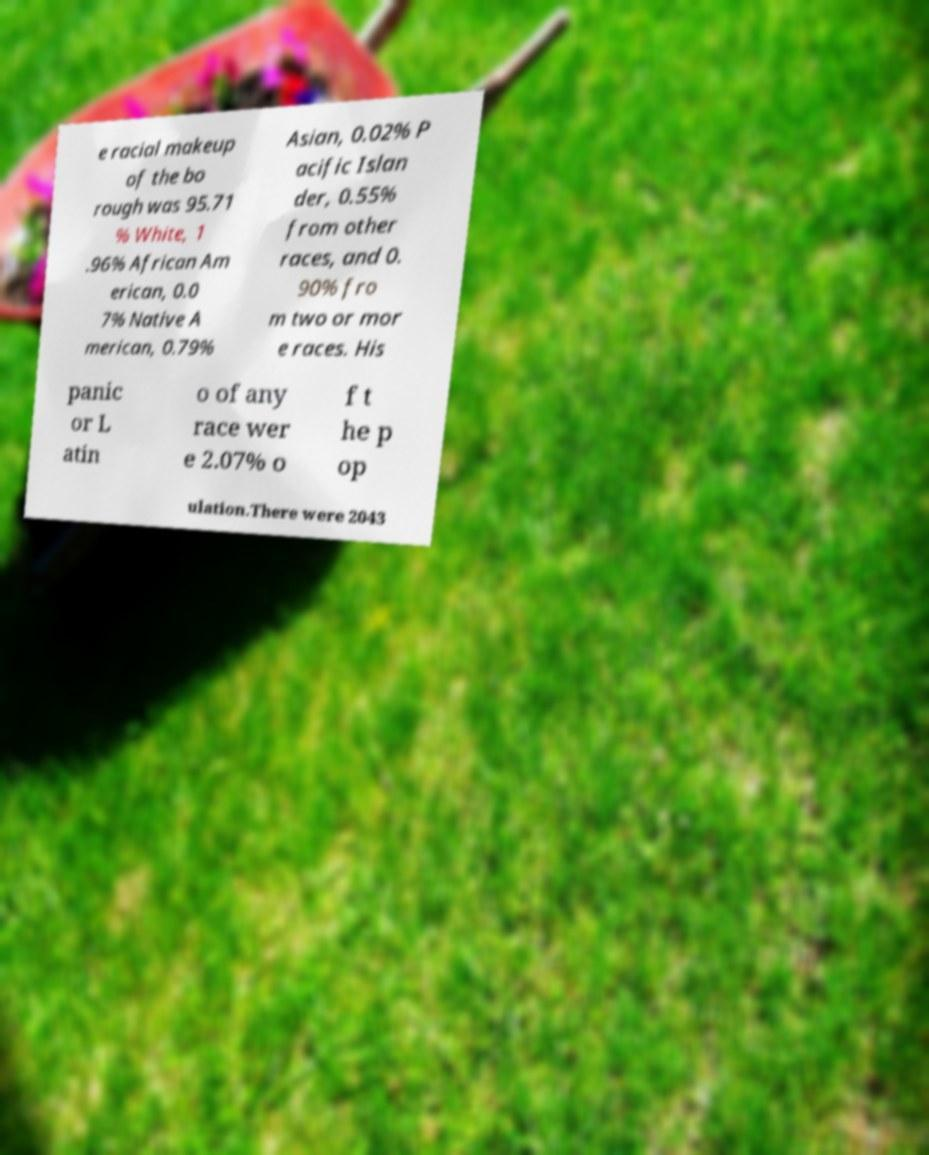There's text embedded in this image that I need extracted. Can you transcribe it verbatim? e racial makeup of the bo rough was 95.71 % White, 1 .96% African Am erican, 0.0 7% Native A merican, 0.79% Asian, 0.02% P acific Islan der, 0.55% from other races, and 0. 90% fro m two or mor e races. His panic or L atin o of any race wer e 2.07% o f t he p op ulation.There were 2043 